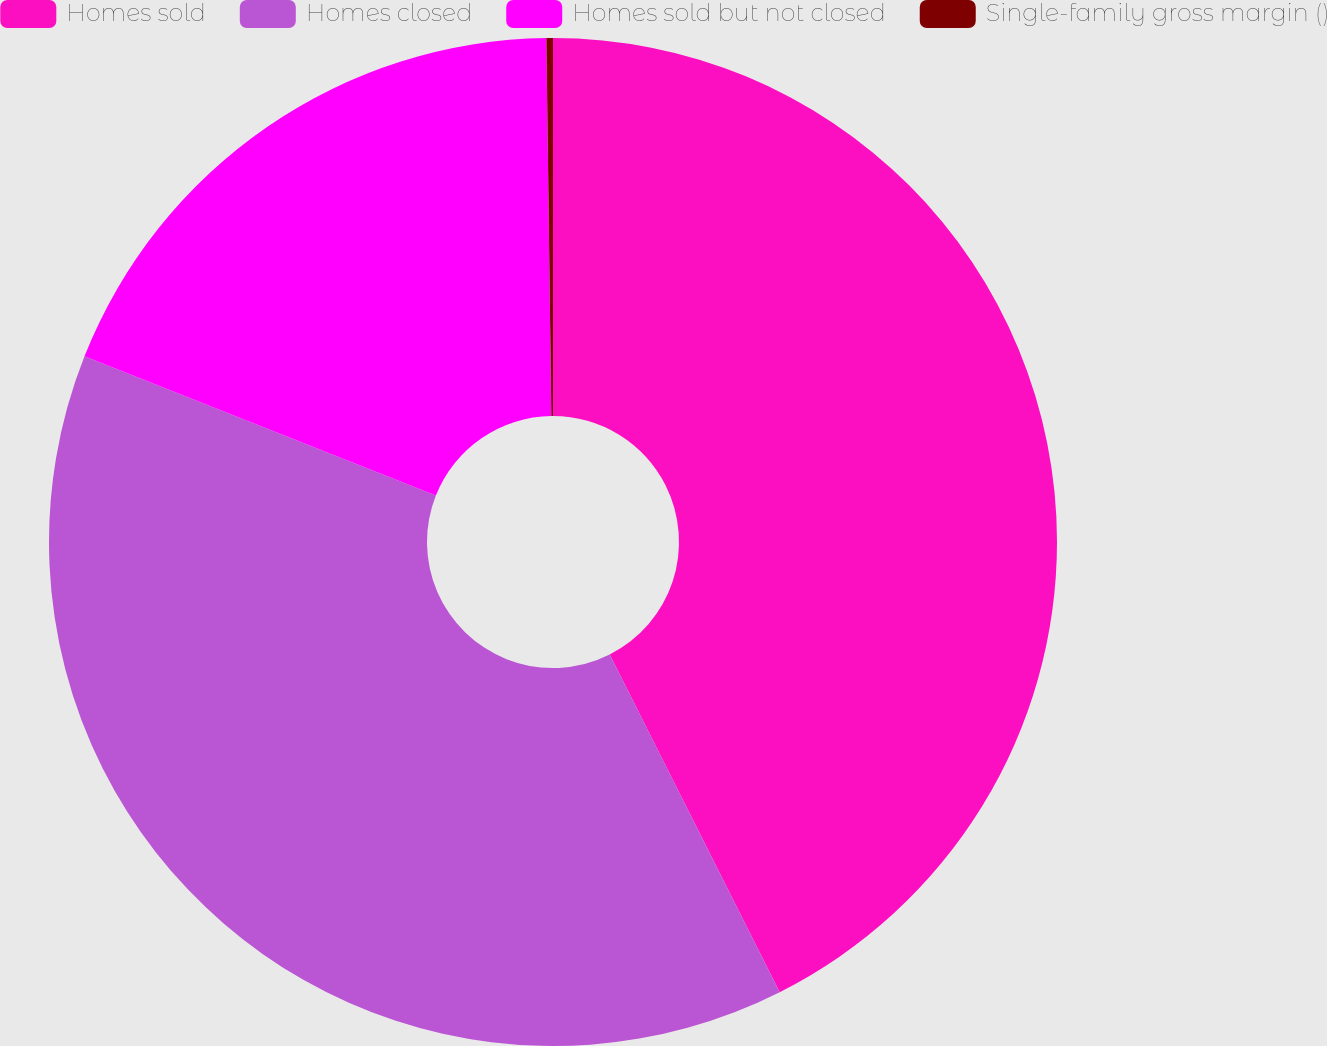Convert chart. <chart><loc_0><loc_0><loc_500><loc_500><pie_chart><fcel>Homes sold<fcel>Homes closed<fcel>Homes sold but not closed<fcel>Single-family gross margin ()<nl><fcel>42.57%<fcel>38.43%<fcel>18.78%<fcel>0.21%<nl></chart> 